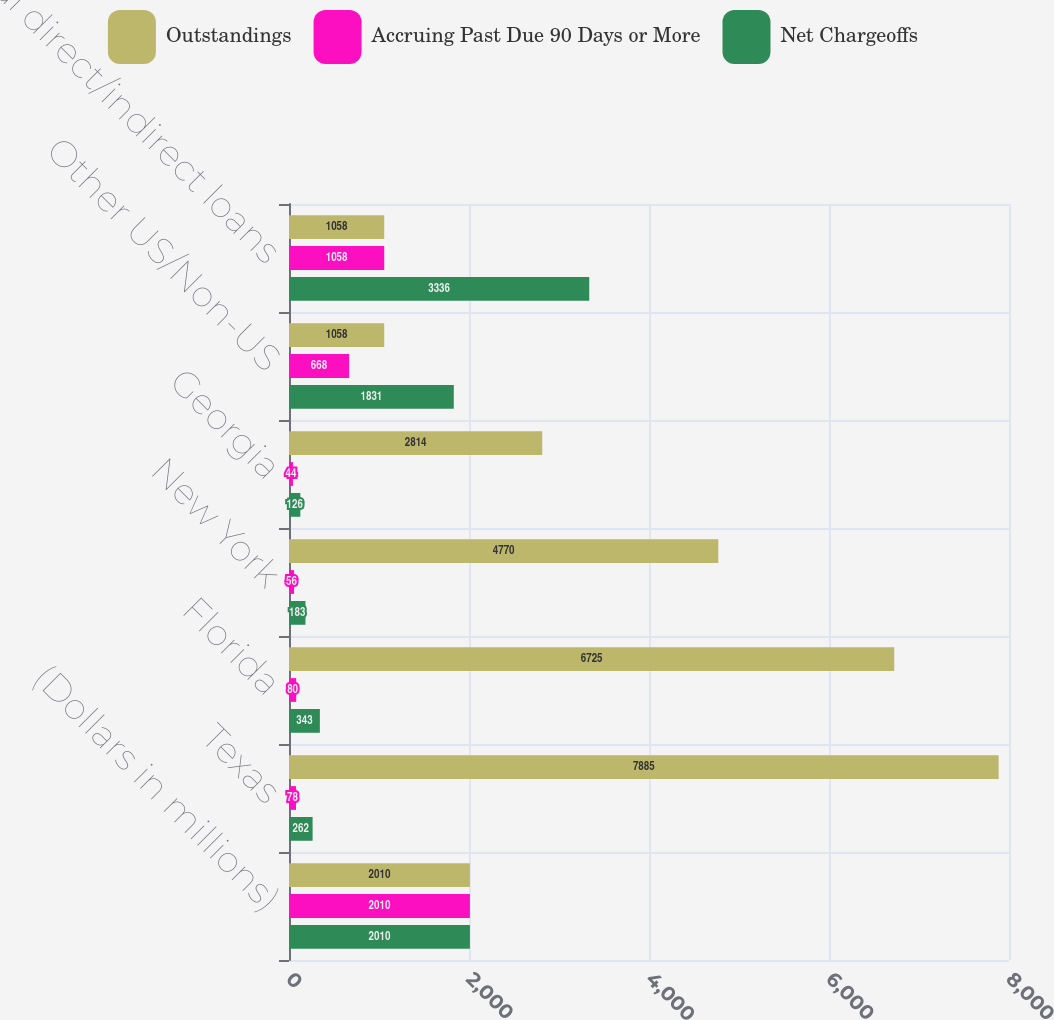<chart> <loc_0><loc_0><loc_500><loc_500><stacked_bar_chart><ecel><fcel>(Dollars in millions)<fcel>Texas<fcel>Florida<fcel>New York<fcel>Georgia<fcel>Other US/Non-US<fcel>Total direct/indirect loans<nl><fcel>Outstandings<fcel>2010<fcel>7885<fcel>6725<fcel>4770<fcel>2814<fcel>1058<fcel>1058<nl><fcel>Accruing Past Due 90 Days or More<fcel>2010<fcel>78<fcel>80<fcel>56<fcel>44<fcel>668<fcel>1058<nl><fcel>Net Chargeoffs<fcel>2010<fcel>262<fcel>343<fcel>183<fcel>126<fcel>1831<fcel>3336<nl></chart> 